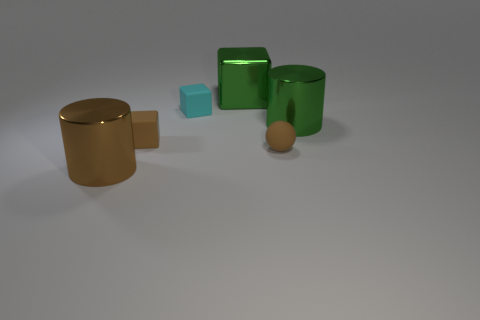The big thing that is behind the small rubber ball and on the left side of the brown sphere has what shape?
Provide a short and direct response. Cube. There is a large cylinder behind the large metal thing that is on the left side of the big green cube; how many big metallic things are in front of it?
Your response must be concise. 1. What size is the brown rubber object that is the same shape as the cyan thing?
Offer a terse response. Small. Is the big object left of the cyan rubber cube made of the same material as the cyan object?
Your answer should be compact. No. There is another small thing that is the same shape as the cyan rubber thing; what color is it?
Provide a succinct answer. Brown. How many other things are there of the same color as the big cube?
Keep it short and to the point. 1. Is the shape of the rubber object to the left of the tiny cyan matte cube the same as the tiny cyan object left of the green block?
Offer a terse response. Yes. What number of spheres are either big brown things or large yellow things?
Offer a very short reply. 0. Are there fewer green objects that are behind the metallic block than large red cylinders?
Provide a succinct answer. No. What number of other objects are the same material as the cyan object?
Offer a terse response. 2. 